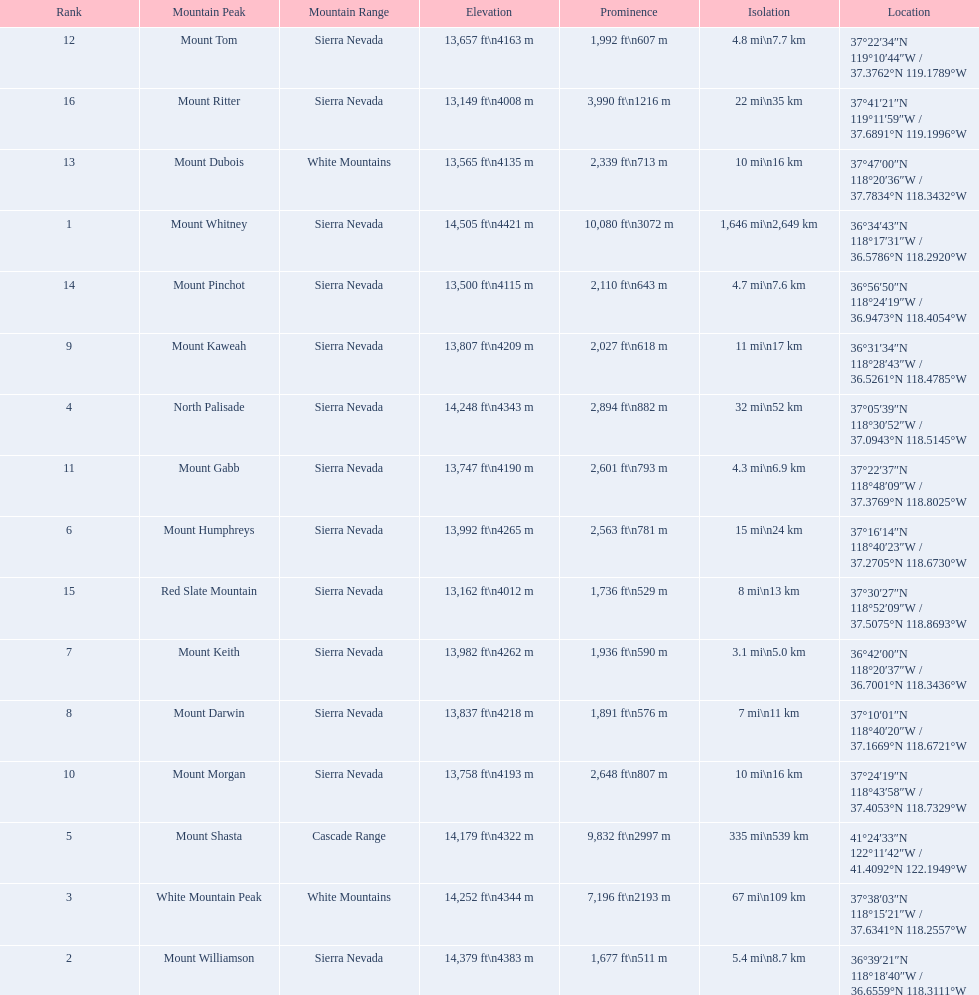What are the peaks in california? Mount Whitney, Mount Williamson, White Mountain Peak, North Palisade, Mount Shasta, Mount Humphreys, Mount Keith, Mount Darwin, Mount Kaweah, Mount Morgan, Mount Gabb, Mount Tom, Mount Dubois, Mount Pinchot, Red Slate Mountain, Mount Ritter. What are the peaks in sierra nevada, california? Mount Whitney, Mount Williamson, North Palisade, Mount Humphreys, Mount Keith, Mount Darwin, Mount Kaweah, Mount Morgan, Mount Gabb, Mount Tom, Mount Pinchot, Red Slate Mountain, Mount Ritter. What are the heights of the peaks in sierra nevada? 14,505 ft\n4421 m, 14,379 ft\n4383 m, 14,248 ft\n4343 m, 13,992 ft\n4265 m, 13,982 ft\n4262 m, 13,837 ft\n4218 m, 13,807 ft\n4209 m, 13,758 ft\n4193 m, 13,747 ft\n4190 m, 13,657 ft\n4163 m, 13,500 ft\n4115 m, 13,162 ft\n4012 m, 13,149 ft\n4008 m. Which is the highest? Mount Whitney. 